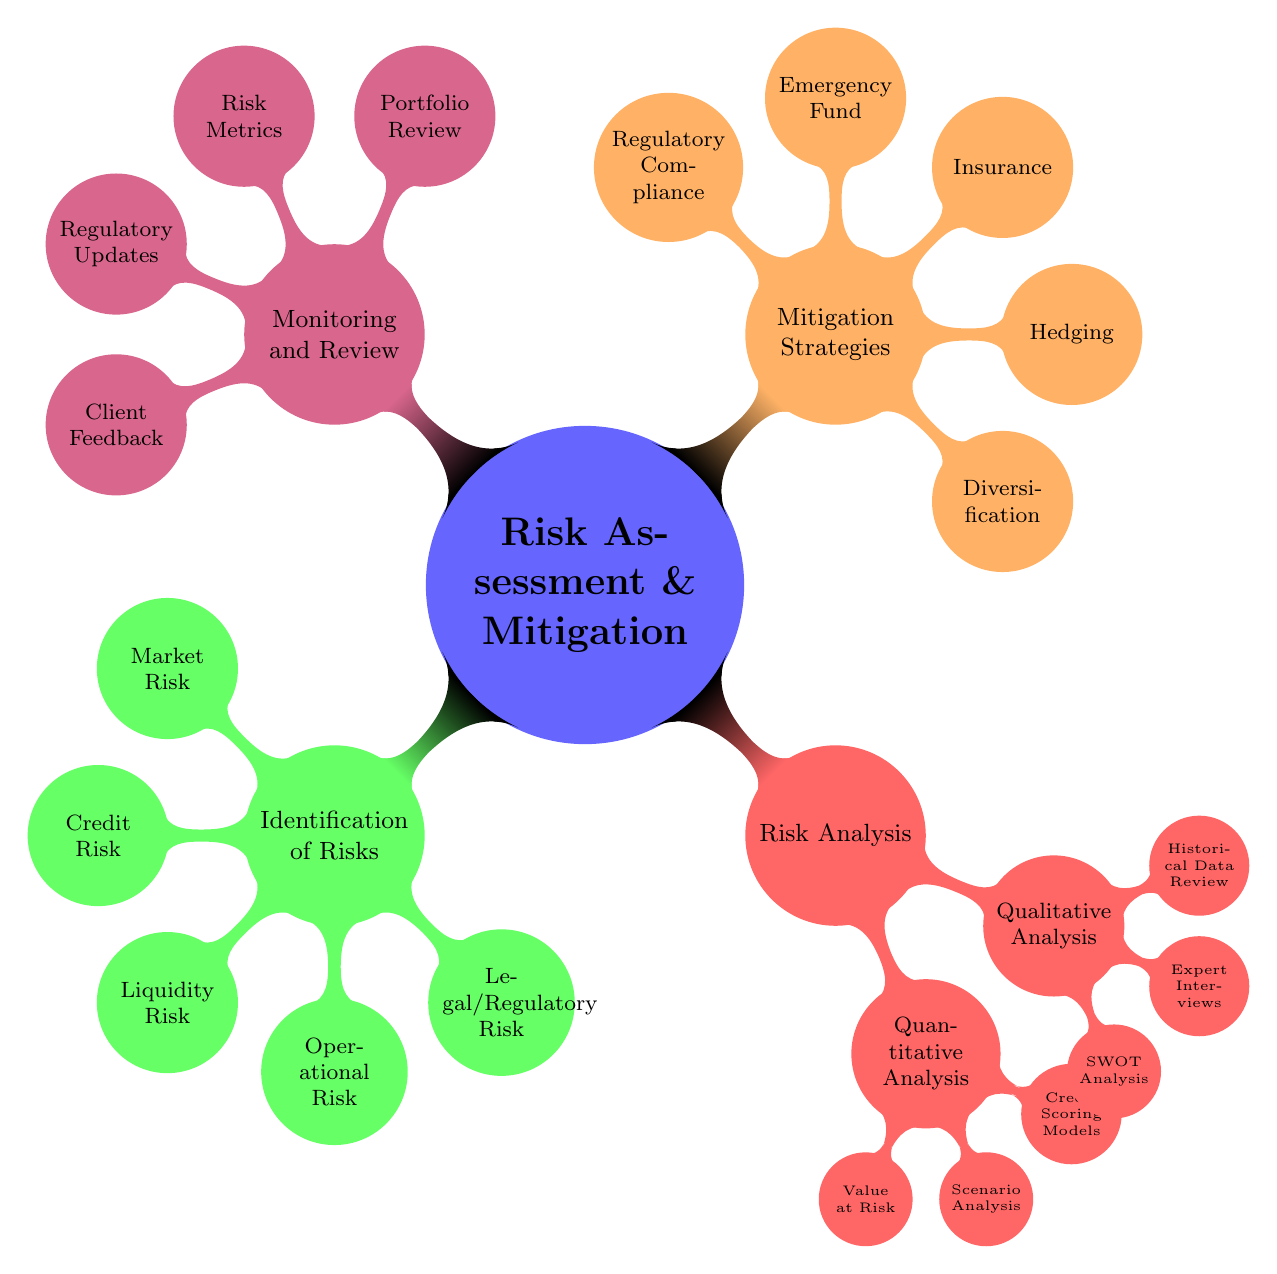What are the categories of risk identified in the mind map? The mind map lists five specific categories under Risk Identification: Market Risk, Credit Risk, Liquidity Risk, Operational Risk, and Legal/Regulatory Risk. Each category is presented as a child node under the main category "Identification of Risks."
Answer: Market Risk, Credit Risk, Liquidity Risk, Operational Risk, Legal/Regulatory Risk How many children nodes are under "Risk Analysis"? The "Risk Analysis" category has two main children: Quantitative Analysis and Qualitative Analysis. Each of these has further child nodes. The counting of primary nodes only gives us a total of two.
Answer: 2 Which risk assessment technique involves consulting market analysts? The technique that involves consulting market analysts is categorized under Qualitative Analysis as "Expert Interviews." It emphasizes the importance of obtaining insights from experts in the assessment process.
Answer: Expert Interviews What is the purpose of "Value at Risk"? "Value at Risk" is a method used in Quantitative Analysis for assessing risk by calculating the potential loss in value of an asset over a defined period for a given confidence interval, which means it helps in predicting financial risk levels.
Answer: VaR Calculations What strategy involves allocating assets across different sectors? The strategy of allocating assets across different sectors is referred to as "Diversification" under the Mitigation Strategies section. This technique aims to reduce risk by spreading investments.
Answer: Diversification Which monitoring method tracks indicators like the Sharpe Ratio? The method used for tracking indicators such as the Sharpe Ratio is classified under "Risk Metrics" within the Monitoring and Review section. This metric helps in measuring risk-adjusted return.
Answer: Risk Metrics How many mitigation strategies are indicated in the mind map? There are five distinct mitigation strategies listed in the mind map, addressing various risk management techniques. They are presented as children under the "Mitigation Strategies" node.
Answer: 5 What is the focus of the "Portfolio Review" in monitoring? "Portfolio Review" focuses on the periodic assessment of asset performance to ensure that investment goals are being met and to make informed decisions about future investments.
Answer: Periodic Assessment of Asset Performance Which category contains the "Regulatory Updates"? "Regulatory Updates" is found in the "Monitoring and Review" category. This indicates that staying updated on regulations is a key aspect of ongoing risk management and compliance.
Answer: Monitoring and Review 